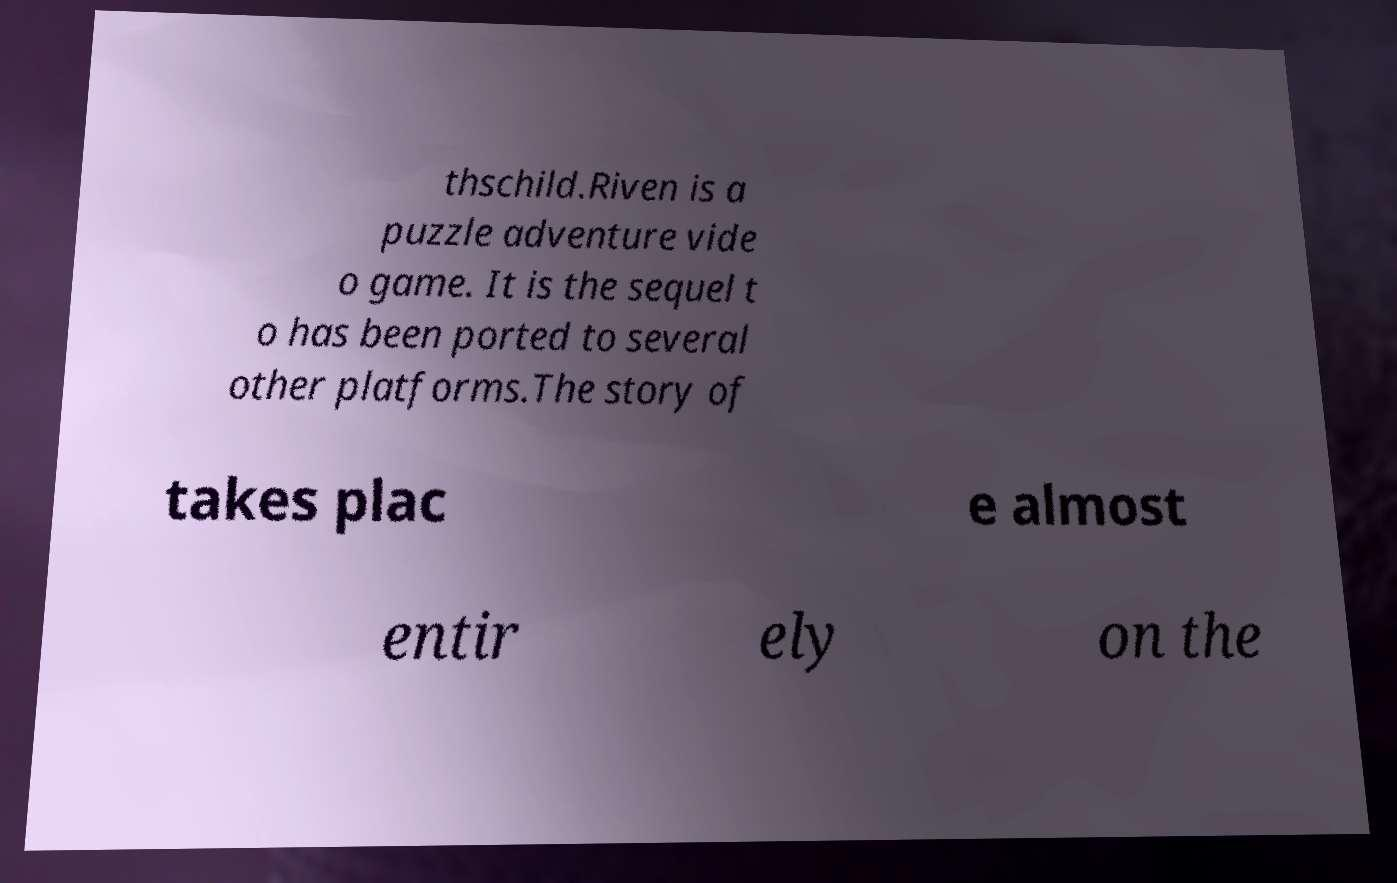Could you extract and type out the text from this image? thschild.Riven is a puzzle adventure vide o game. It is the sequel t o has been ported to several other platforms.The story of takes plac e almost entir ely on the 